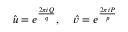<formula> <loc_0><loc_0><loc_500><loc_500>\hat { u } = e ^ { \frac { 2 \pi i Q } { q } } , \, \hat { v } = e ^ { \frac { 2 \pi i P } { p } }</formula> 